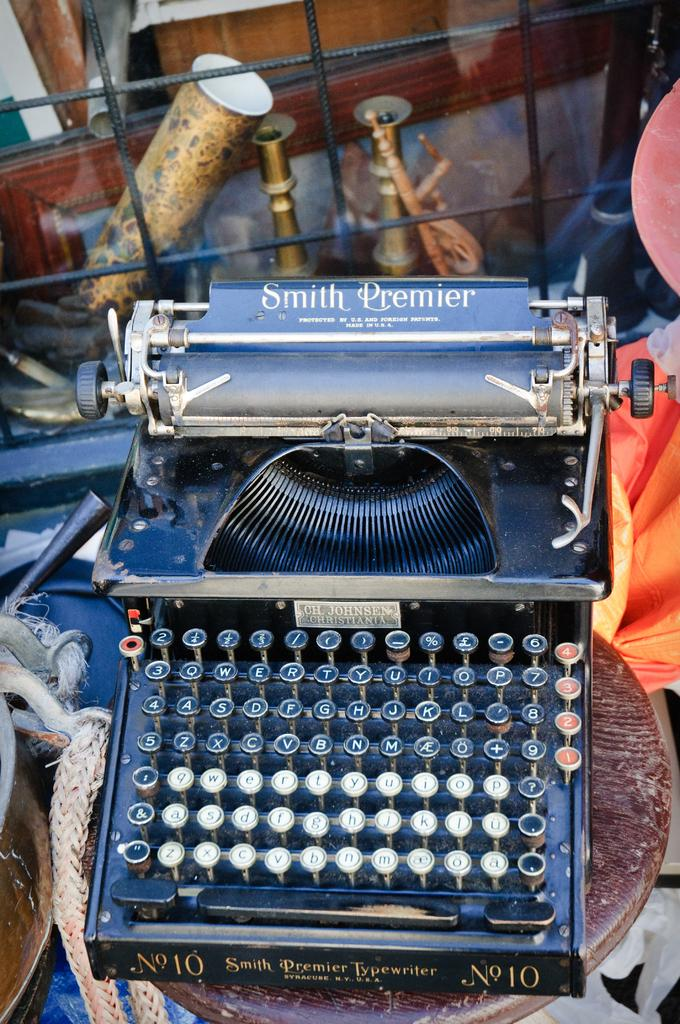Provide a one-sentence caption for the provided image. A typewriter, made by Smith Premier, has black and white keys. 